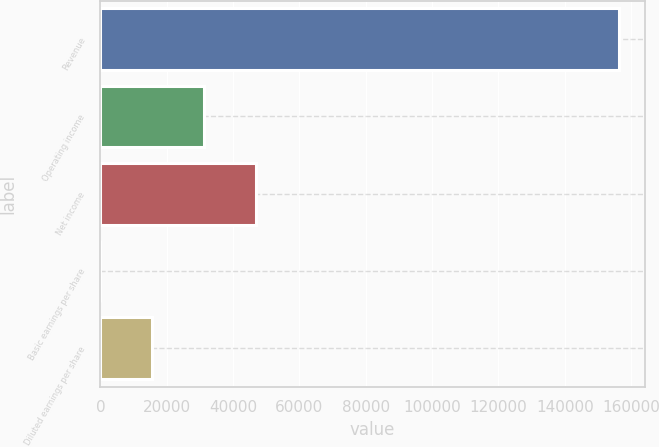Convert chart to OTSL. <chart><loc_0><loc_0><loc_500><loc_500><bar_chart><fcel>Revenue<fcel>Operating income<fcel>Net income<fcel>Basic earnings per share<fcel>Diluted earnings per share<nl><fcel>156296<fcel>31260<fcel>46889.5<fcel>0.98<fcel>15630.5<nl></chart> 